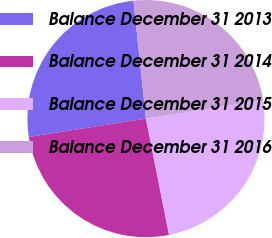Convert chart. <chart><loc_0><loc_0><loc_500><loc_500><pie_chart><fcel>Balance December 31 2013<fcel>Balance December 31 2014<fcel>Balance December 31 2015<fcel>Balance December 31 2016<nl><fcel>25.79%<fcel>25.64%<fcel>24.36%<fcel>24.21%<nl></chart> 